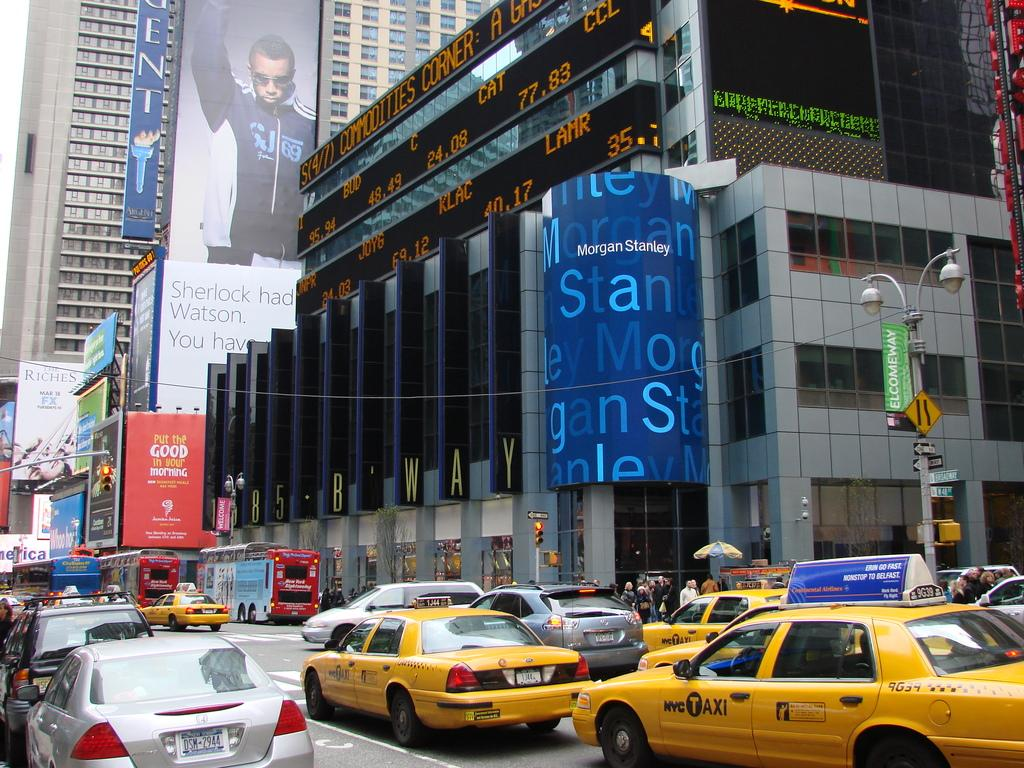<image>
Relay a brief, clear account of the picture shown. A congested metro street scene with an entrance to Morgan Stanley in the middle. 